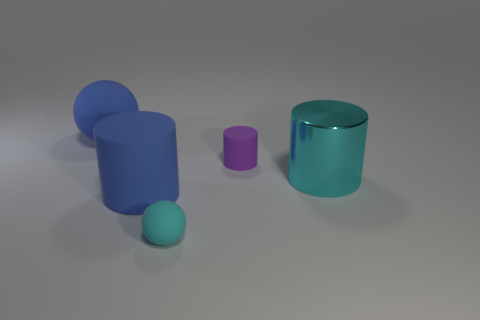Subtract all large cylinders. How many cylinders are left? 1 Subtract all cylinders. How many objects are left? 2 Add 2 blue rubber cylinders. How many objects exist? 7 Subtract all cyan balls. How many balls are left? 1 Subtract 0 purple cubes. How many objects are left? 5 Subtract 2 cylinders. How many cylinders are left? 1 Subtract all blue balls. Subtract all gray cylinders. How many balls are left? 1 Subtract all yellow cylinders. How many green balls are left? 0 Subtract all small cyan balls. Subtract all tiny objects. How many objects are left? 2 Add 3 tiny cylinders. How many tiny cylinders are left? 4 